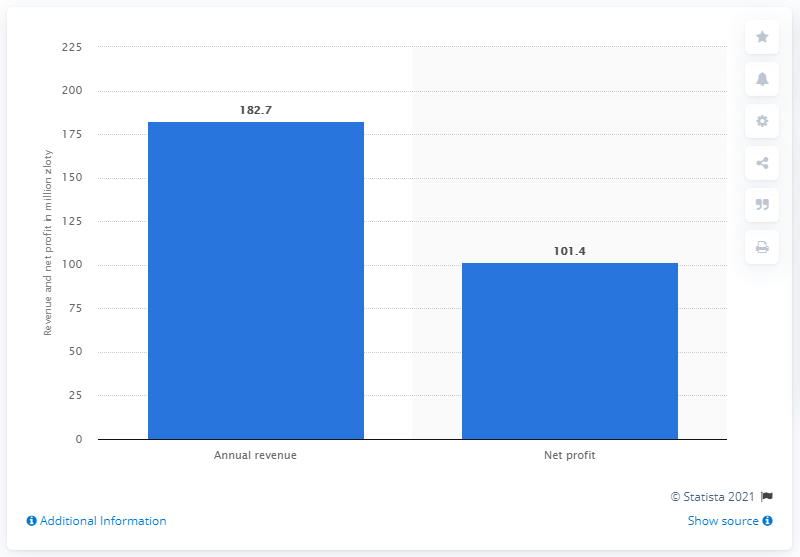List a handful of essential elements in this visual. In 2018, Techland's revenue was 182.7 million US dollars. Techland's net profit in 2018 was 101.4 million. 